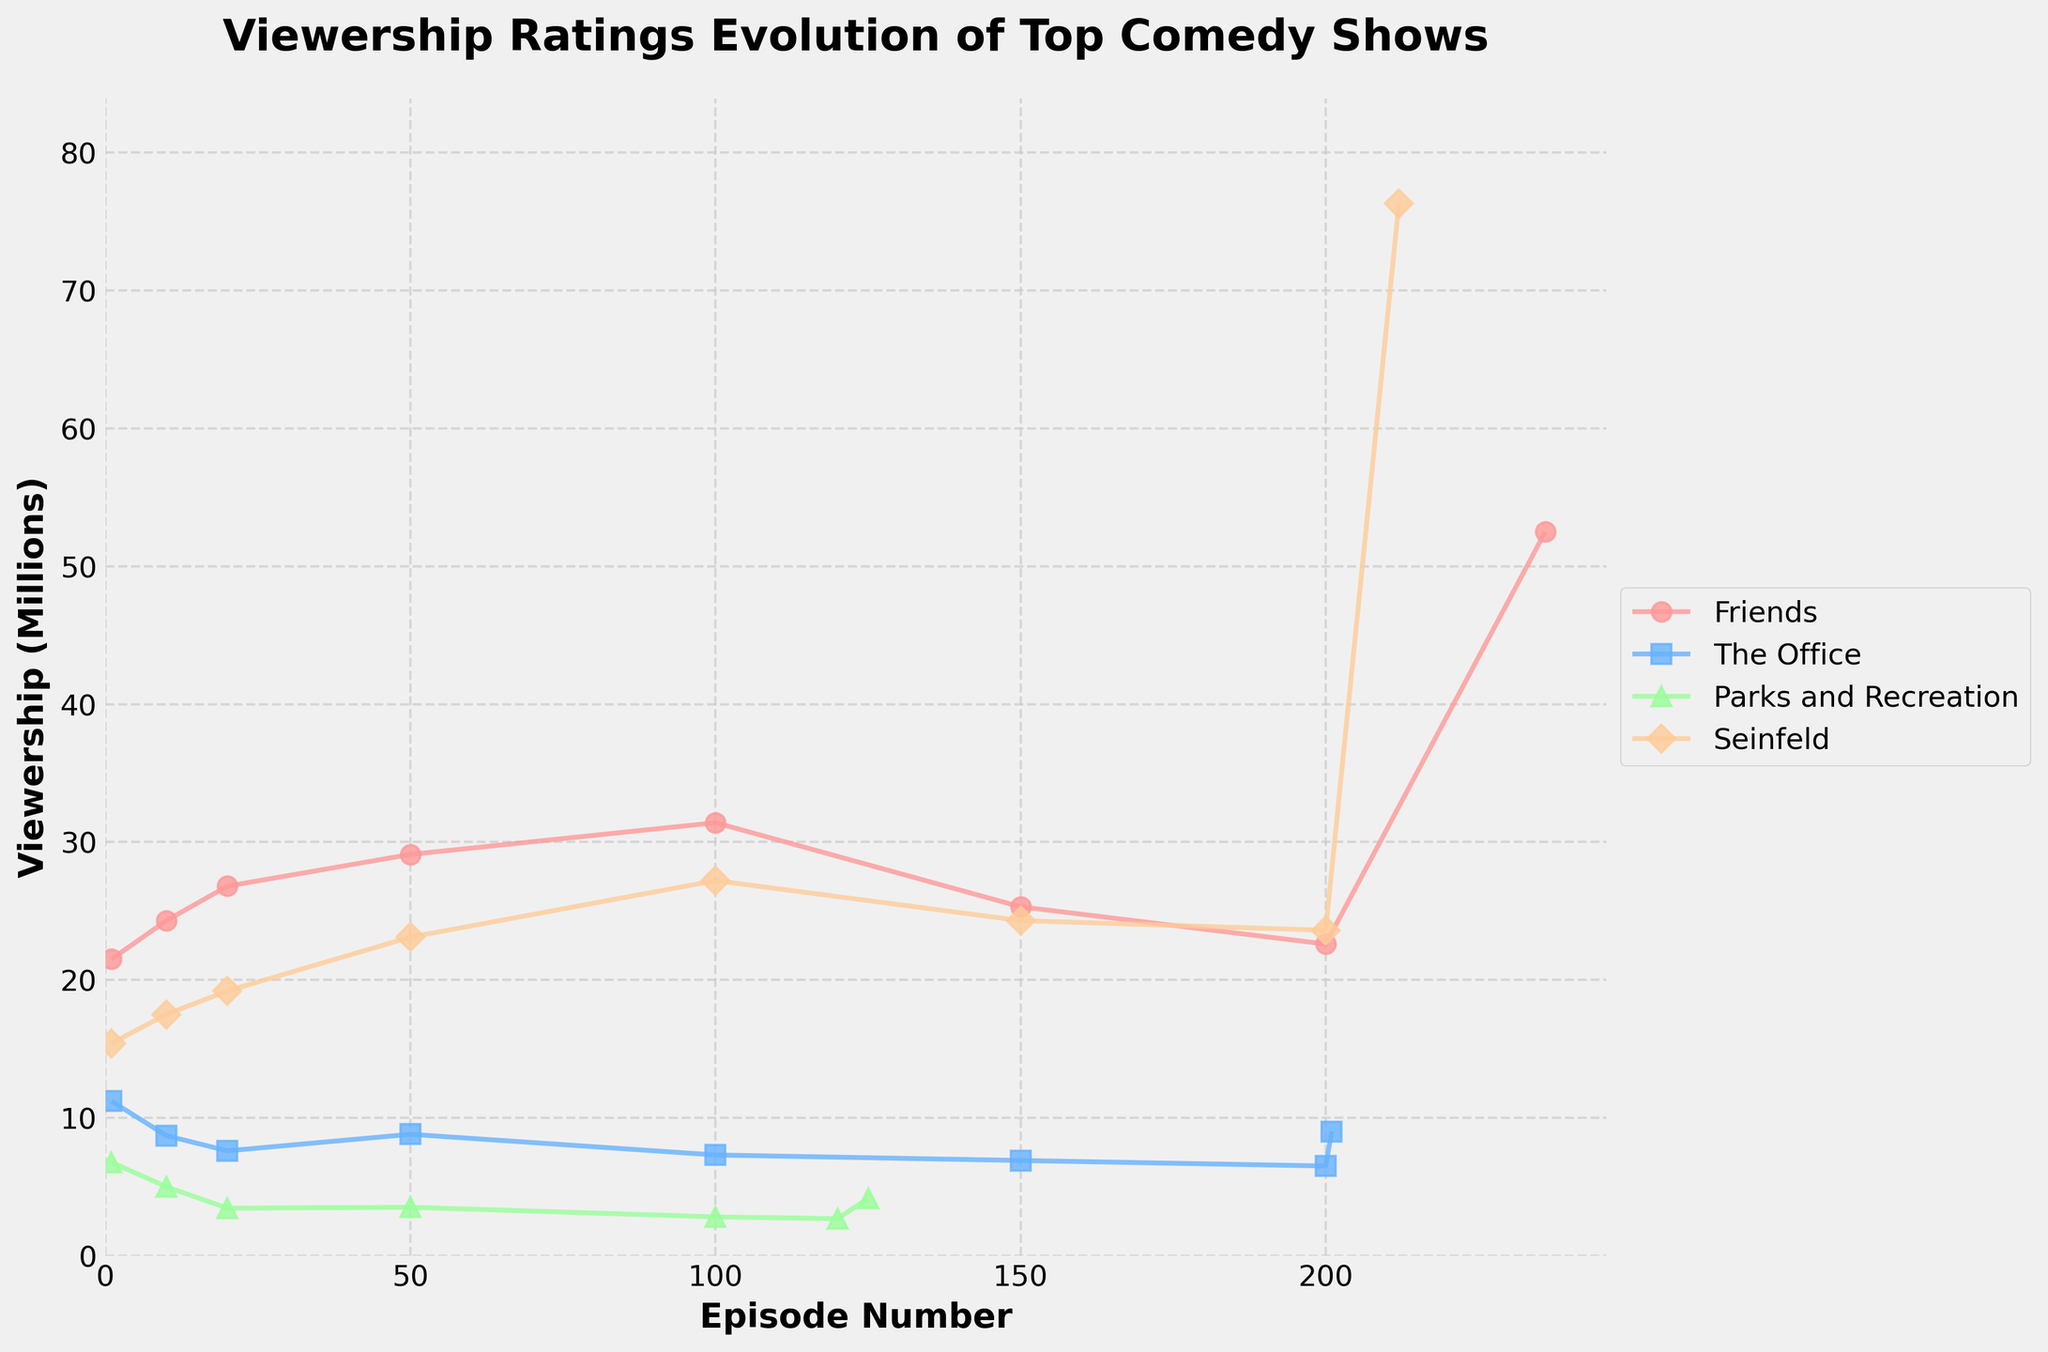what is the title of the figure? The title is displayed in bold at the top of the figure. The phrase "Viewership Ratings Evolution of Top Comedy Shows" indicates what the plot is about.
Answer: Viewership Ratings Evolution of Top Comedy Shows How many comedy shows are represented in the figure? The legend on the right side of the plot lists all the comedy shows. Counting the entries in the legend will give us the answer.
Answer: Four What is the highest viewership rating observed and for which show and episode? By looking at the peaks of the lines in the plot, we can identify the maximum value. The specific value can be located on the y-axis. We also need to use the legend and x-axis to determine the show and episode.
Answer: Seinfeld, The Finale, 76.3 million Which show had the lowest viewership rating for its pilot episode? Trace each show to its starting point on the x-axis (episode number 1). Compare the corresponding y-axis values to find the lowest one.
Answer: Parks and Recreation What show had the most significant spike in viewership ratings from one episode to another? By examining the plot for the steepest upward slope between any two consecutive points, we identify the show and episode with the largest increase. This involves looking for the sharpest rise in the lines.
Answer: Friends, from Episode 200 to 236 Which show had a relatively steady viewership trend with minimal fluctuations? Observing the lines of each show, the one with the least variation in ups and downs represents a steady trend. The 'Friends' series tends to show less fluctuation compared to others like 'The Office' and 'Parks and Recreation.'
Answer: Friends On average, did the viewership ratings for 'The Office' trend upwards or downwards over its current range of episodes, and how can we conclude this from the figure? Analyze the general direction of the line plotted for 'The Office' from its pilot episode to its finale. If it trends downward, the average viewership decreases; if upward, it increases.
Answer: Downwards Which show experienced a notable decline in viewership towards its later episodes? Calculate the slope of the line segments for each series towards the later episodes. A rapid descent towards the rightmost part of the plot will indicate a decline. 'Parks and Recreation' shows a considerable drop in viewership as the series progresses.
Answer: Parks and Recreation What is the difference in viewership between 'Friends' and 'The Office' for their final episodes? Identify the final episode viewership value of both 'Friends' and 'The Office' from the plot. Subtract the viewership of 'The Office' from that of 'Friends' to find the difference.
Answer: 43.5 million 